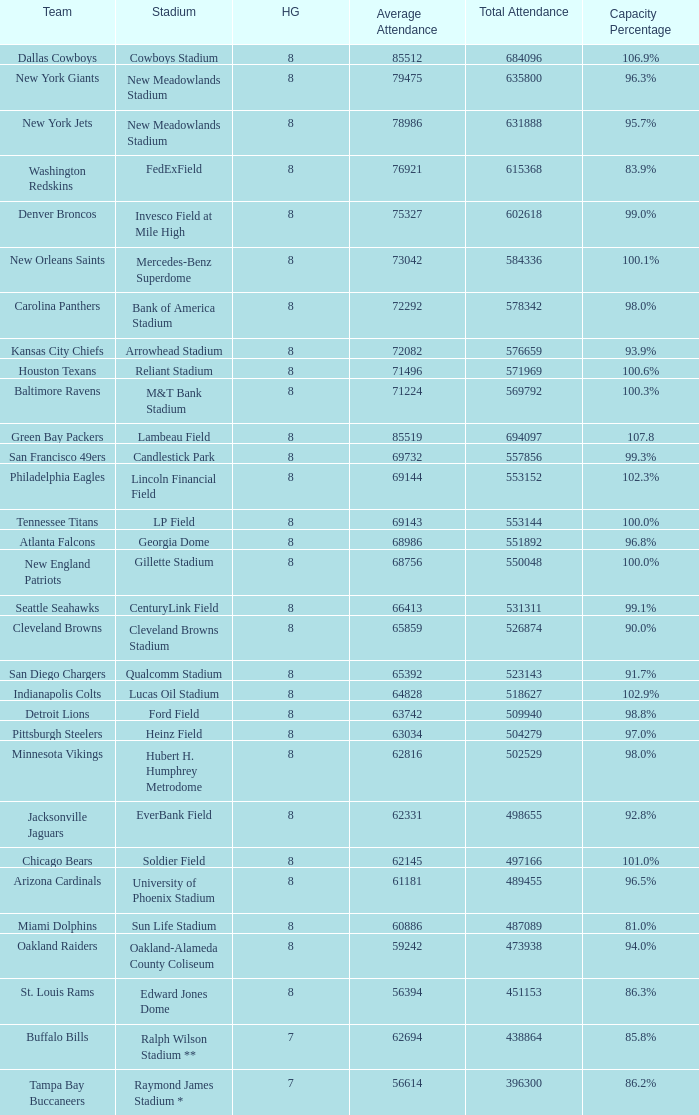What is the name of the stadium when the capacity percentage is 83.9% FedExField. 